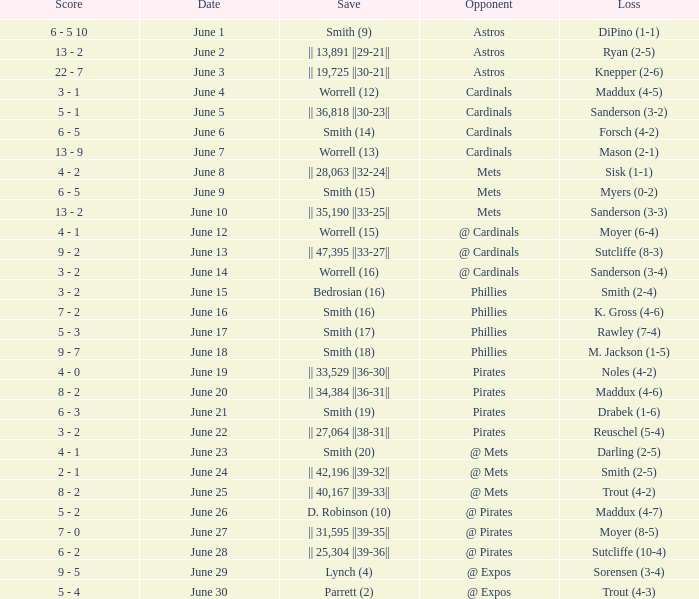What is the loss for the game against @ expos, with a save of parrett (2)? Trout (4-3). 